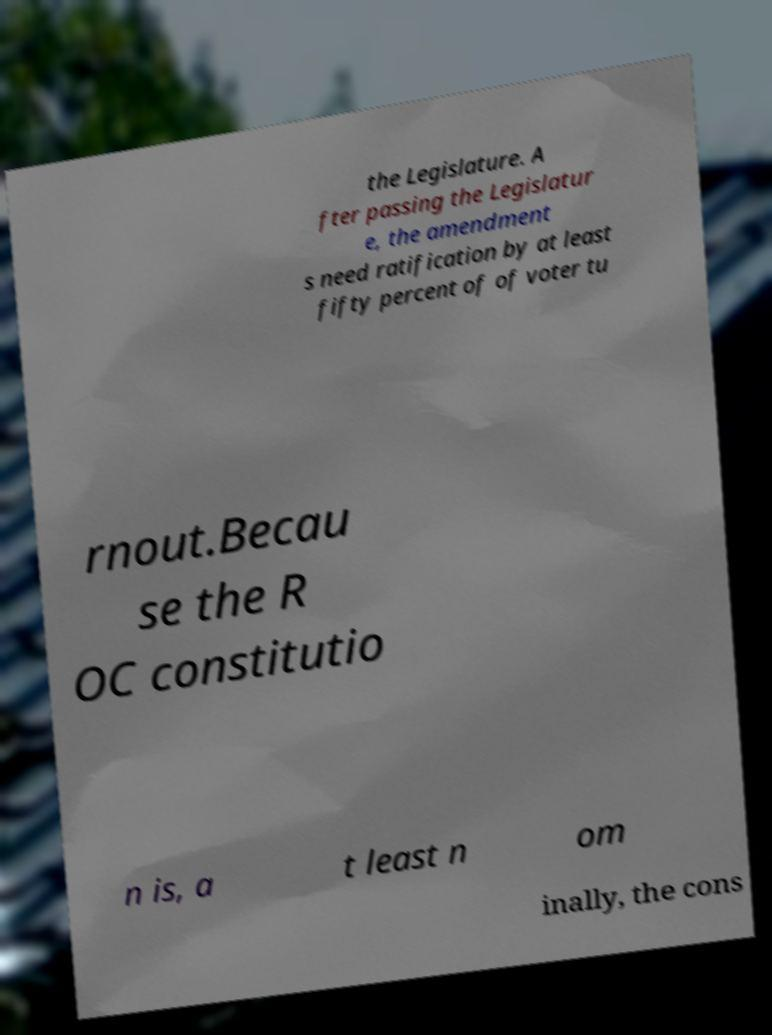Can you accurately transcribe the text from the provided image for me? the Legislature. A fter passing the Legislatur e, the amendment s need ratification by at least fifty percent of of voter tu rnout.Becau se the R OC constitutio n is, a t least n om inally, the cons 